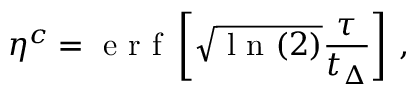Convert formula to latex. <formula><loc_0><loc_0><loc_500><loc_500>{ \eta } ^ { c } = e r f \left [ \sqrt { l n ( 2 ) } \frac { \tau } { t _ { \Delta } } \right ] \, ,</formula> 